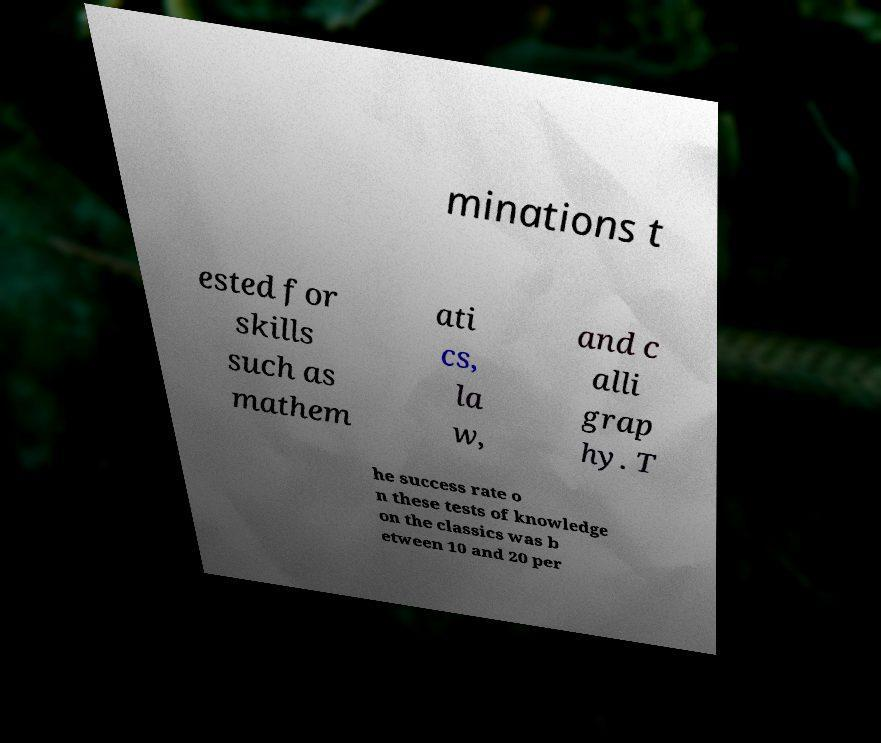Can you accurately transcribe the text from the provided image for me? minations t ested for skills such as mathem ati cs, la w, and c alli grap hy. T he success rate o n these tests of knowledge on the classics was b etween 10 and 20 per 